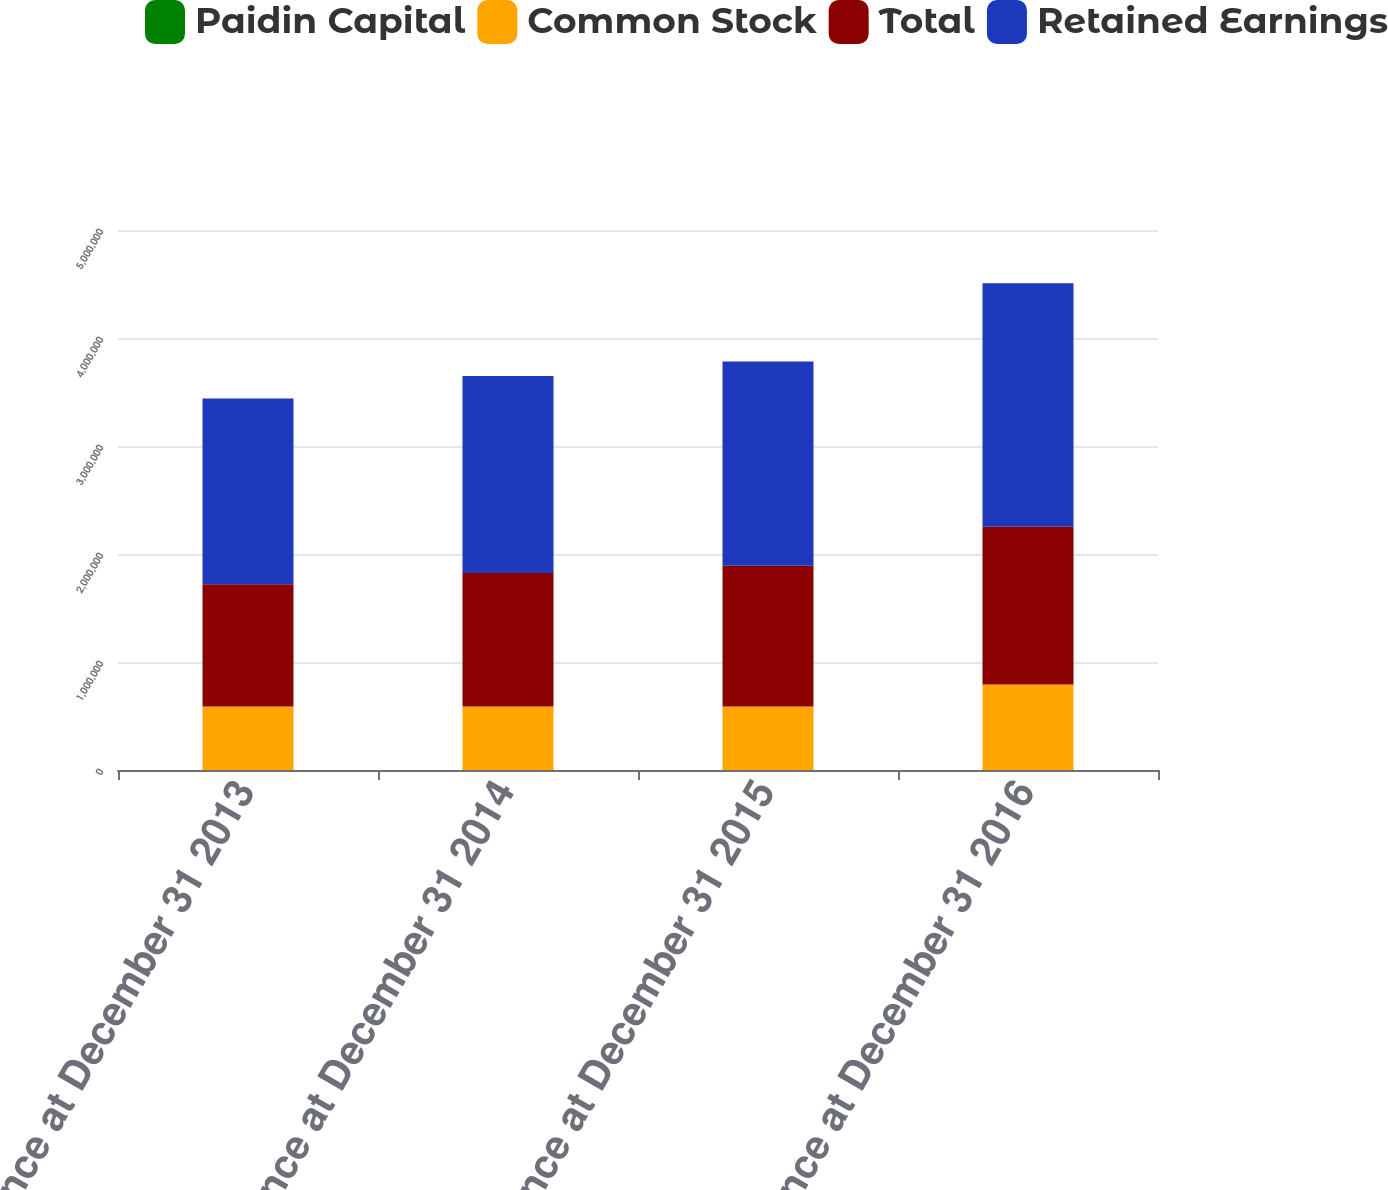Convert chart to OTSL. <chart><loc_0><loc_0><loc_500><loc_500><stacked_bar_chart><ecel><fcel>Balance at December 31 2013<fcel>Balance at December 31 2014<fcel>Balance at December 31 2015<fcel>Balance at December 31 2016<nl><fcel>Paidin Capital<fcel>470<fcel>470<fcel>470<fcel>470<nl><fcel>Common Stock<fcel>588471<fcel>588471<fcel>588493<fcel>790243<nl><fcel>Total<fcel>1.13078e+06<fcel>1.2353e+06<fcel>1.3027e+06<fcel>1.4626e+06<nl><fcel>Retained Earnings<fcel>1.71972e+06<fcel>1.82424e+06<fcel>1.89166e+06<fcel>2.25332e+06<nl></chart> 